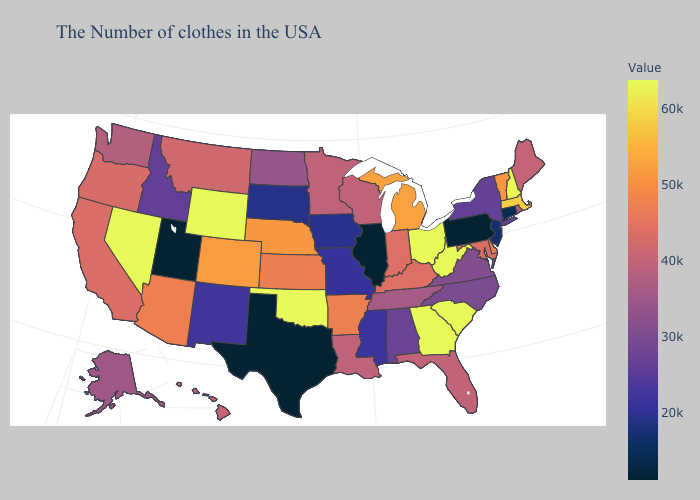Does Hawaii have a lower value than New Mexico?
Short answer required. No. Does Ohio have the highest value in the MidWest?
Answer briefly. Yes. Does Oregon have the lowest value in the USA?
Keep it brief. No. Does Illinois have the lowest value in the MidWest?
Short answer required. Yes. Does the map have missing data?
Answer briefly. No. 